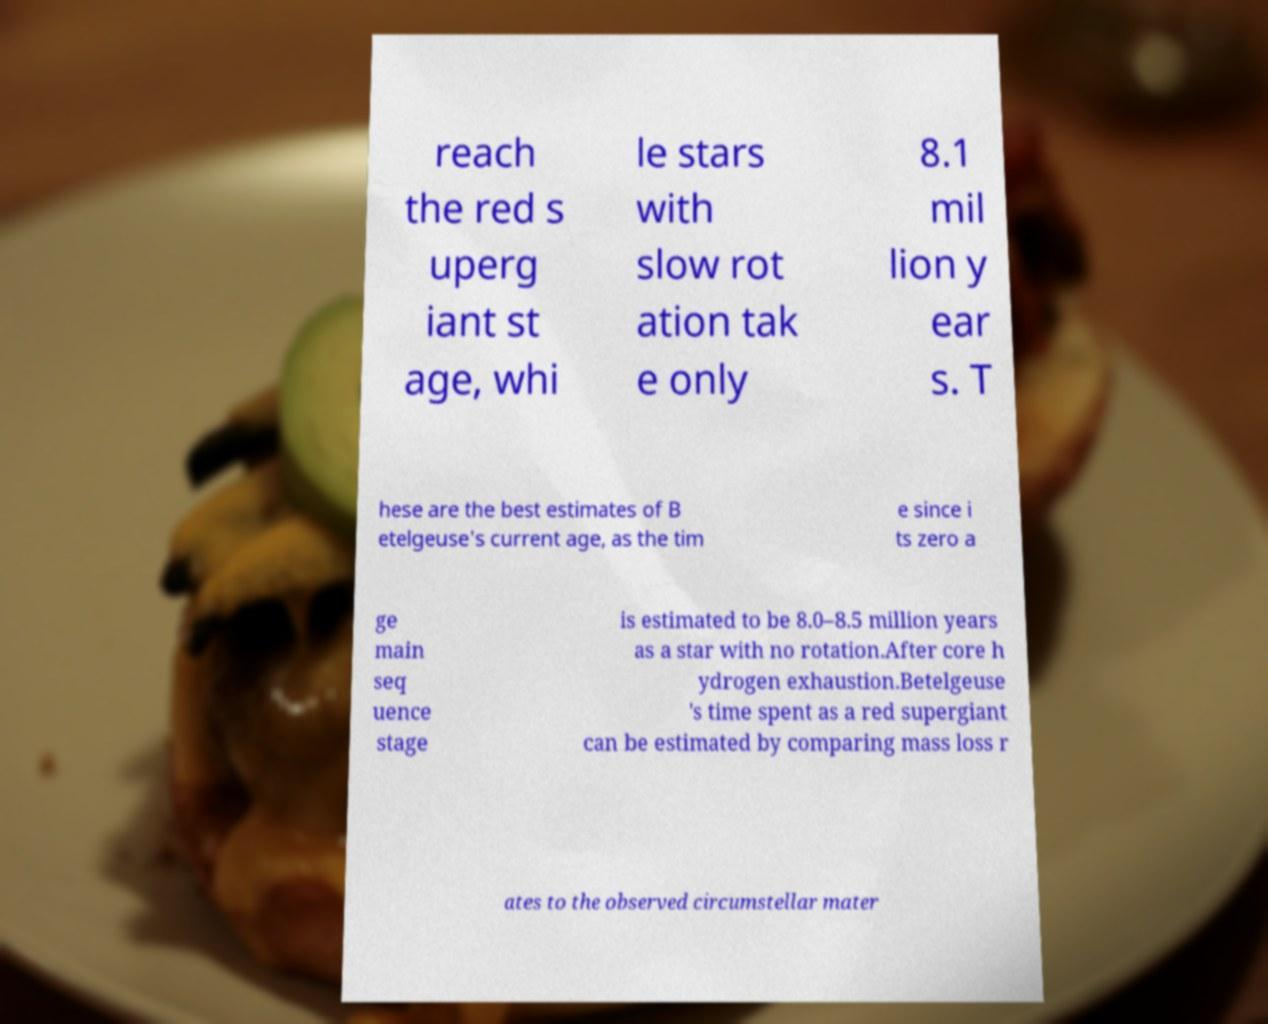Can you read and provide the text displayed in the image?This photo seems to have some interesting text. Can you extract and type it out for me? reach the red s uperg iant st age, whi le stars with slow rot ation tak e only 8.1 mil lion y ear s. T hese are the best estimates of B etelgeuse's current age, as the tim e since i ts zero a ge main seq uence stage is estimated to be 8.0–8.5 million years as a star with no rotation.After core h ydrogen exhaustion.Betelgeuse 's time spent as a red supergiant can be estimated by comparing mass loss r ates to the observed circumstellar mater 